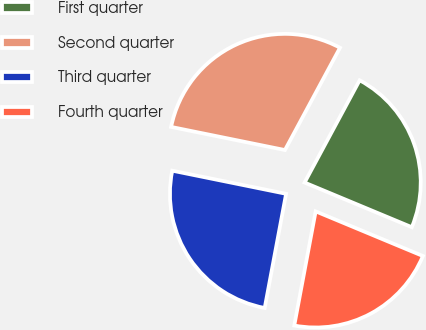<chart> <loc_0><loc_0><loc_500><loc_500><pie_chart><fcel>First quarter<fcel>Second quarter<fcel>Third quarter<fcel>Fourth quarter<nl><fcel>23.42%<fcel>29.67%<fcel>25.24%<fcel>21.67%<nl></chart> 